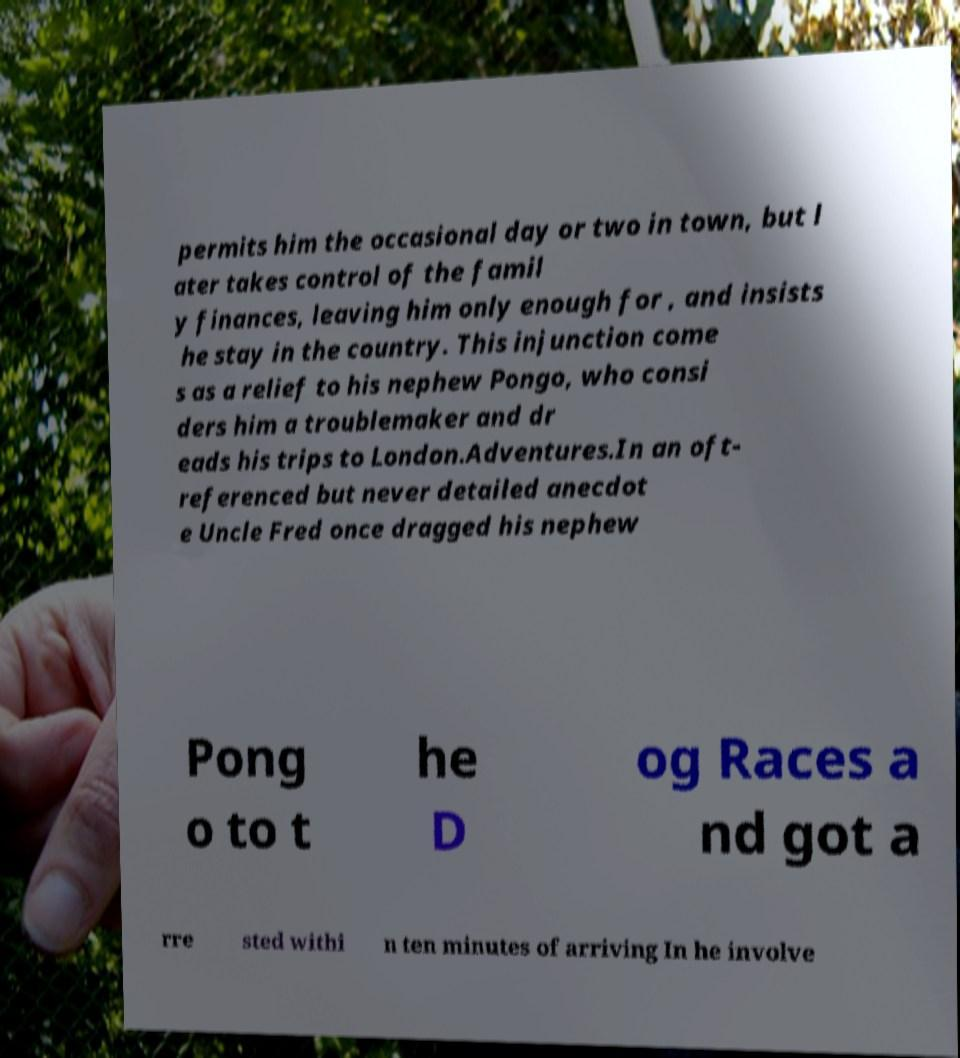Can you accurately transcribe the text from the provided image for me? permits him the occasional day or two in town, but l ater takes control of the famil y finances, leaving him only enough for , and insists he stay in the country. This injunction come s as a relief to his nephew Pongo, who consi ders him a troublemaker and dr eads his trips to London.Adventures.In an oft- referenced but never detailed anecdot e Uncle Fred once dragged his nephew Pong o to t he D og Races a nd got a rre sted withi n ten minutes of arriving In he involve 